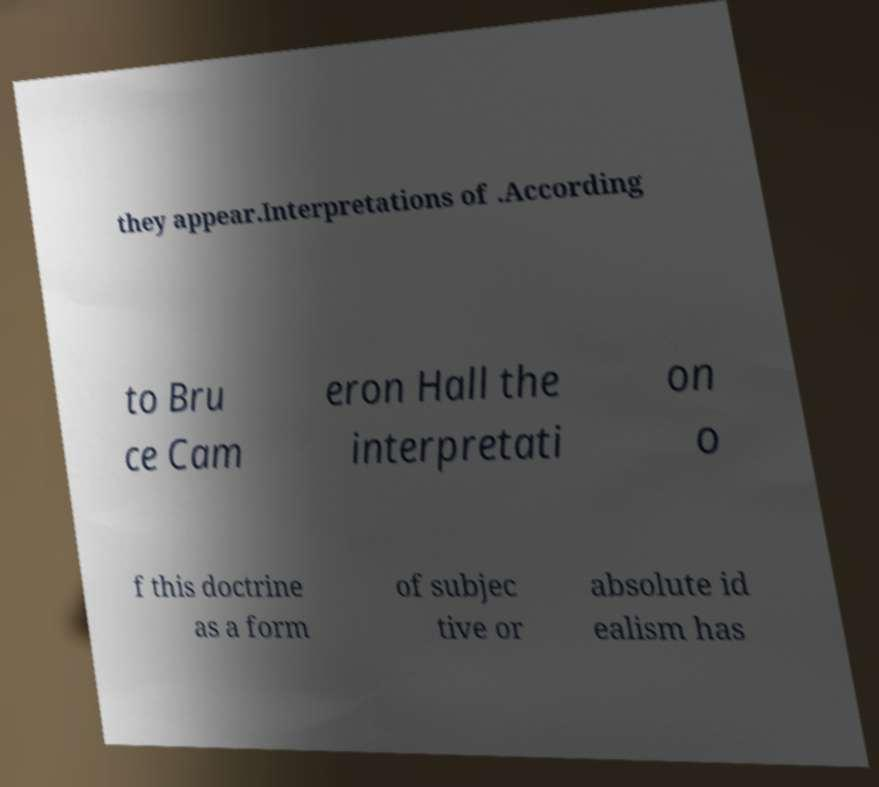Can you read and provide the text displayed in the image?This photo seems to have some interesting text. Can you extract and type it out for me? they appear.Interpretations of .According to Bru ce Cam eron Hall the interpretati on o f this doctrine as a form of subjec tive or absolute id ealism has 